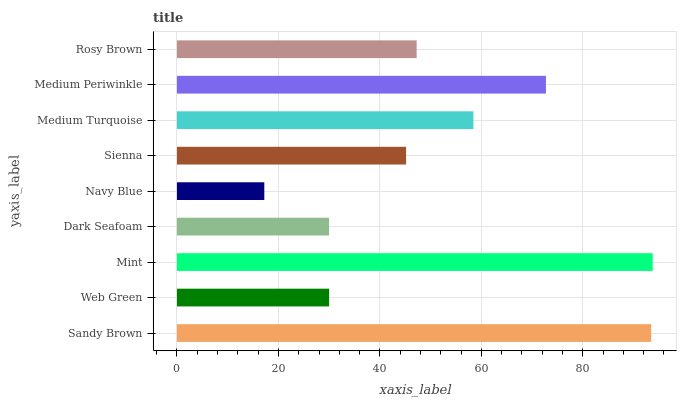Is Navy Blue the minimum?
Answer yes or no. Yes. Is Mint the maximum?
Answer yes or no. Yes. Is Web Green the minimum?
Answer yes or no. No. Is Web Green the maximum?
Answer yes or no. No. Is Sandy Brown greater than Web Green?
Answer yes or no. Yes. Is Web Green less than Sandy Brown?
Answer yes or no. Yes. Is Web Green greater than Sandy Brown?
Answer yes or no. No. Is Sandy Brown less than Web Green?
Answer yes or no. No. Is Rosy Brown the high median?
Answer yes or no. Yes. Is Rosy Brown the low median?
Answer yes or no. Yes. Is Sandy Brown the high median?
Answer yes or no. No. Is Web Green the low median?
Answer yes or no. No. 